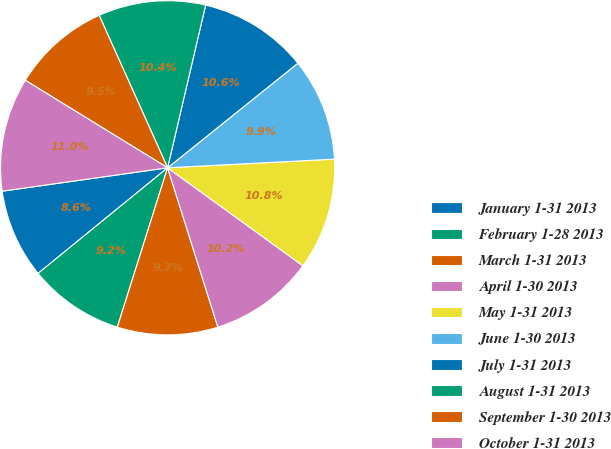<chart> <loc_0><loc_0><loc_500><loc_500><pie_chart><fcel>January 1-31 2013<fcel>February 1-28 2013<fcel>March 1-31 2013<fcel>April 1-30 2013<fcel>May 1-31 2013<fcel>June 1-30 2013<fcel>July 1-31 2013<fcel>August 1-31 2013<fcel>September 1-30 2013<fcel>October 1-31 2013<nl><fcel>8.65%<fcel>9.25%<fcel>9.73%<fcel>10.16%<fcel>10.8%<fcel>9.94%<fcel>10.58%<fcel>10.37%<fcel>9.51%<fcel>11.01%<nl></chart> 